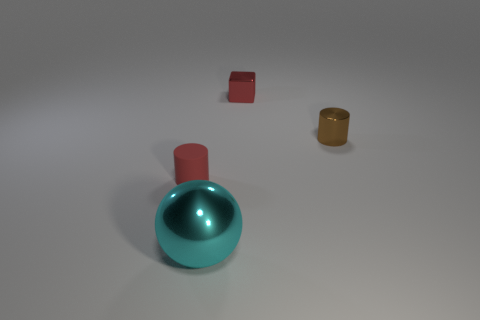Subtract all balls. How many objects are left? 3 Subtract 1 cylinders. How many cylinders are left? 1 Add 2 tiny matte blocks. How many objects exist? 6 Subtract all red cubes. How many brown cylinders are left? 1 Subtract all balls. Subtract all small yellow matte cylinders. How many objects are left? 3 Add 2 small red metallic objects. How many small red metallic objects are left? 3 Add 1 big blue metal cylinders. How many big blue metal cylinders exist? 1 Subtract 1 red cylinders. How many objects are left? 3 Subtract all blue cylinders. Subtract all green cubes. How many cylinders are left? 2 